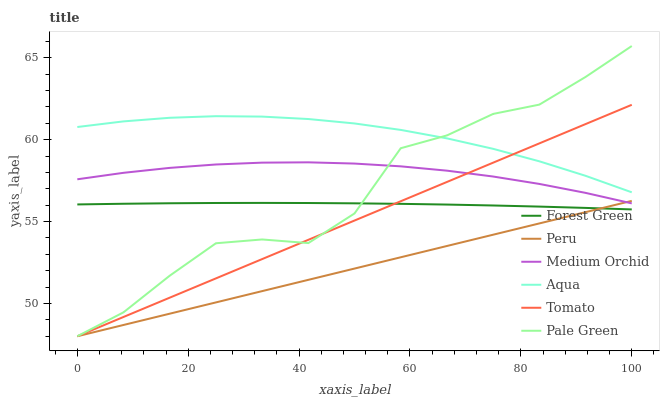Does Peru have the minimum area under the curve?
Answer yes or no. Yes. Does Aqua have the maximum area under the curve?
Answer yes or no. Yes. Does Medium Orchid have the minimum area under the curve?
Answer yes or no. No. Does Medium Orchid have the maximum area under the curve?
Answer yes or no. No. Is Peru the smoothest?
Answer yes or no. Yes. Is Pale Green the roughest?
Answer yes or no. Yes. Is Medium Orchid the smoothest?
Answer yes or no. No. Is Medium Orchid the roughest?
Answer yes or no. No. Does Tomato have the lowest value?
Answer yes or no. Yes. Does Medium Orchid have the lowest value?
Answer yes or no. No. Does Pale Green have the highest value?
Answer yes or no. Yes. Does Medium Orchid have the highest value?
Answer yes or no. No. Is Peru less than Aqua?
Answer yes or no. Yes. Is Aqua greater than Forest Green?
Answer yes or no. Yes. Does Medium Orchid intersect Pale Green?
Answer yes or no. Yes. Is Medium Orchid less than Pale Green?
Answer yes or no. No. Is Medium Orchid greater than Pale Green?
Answer yes or no. No. Does Peru intersect Aqua?
Answer yes or no. No. 